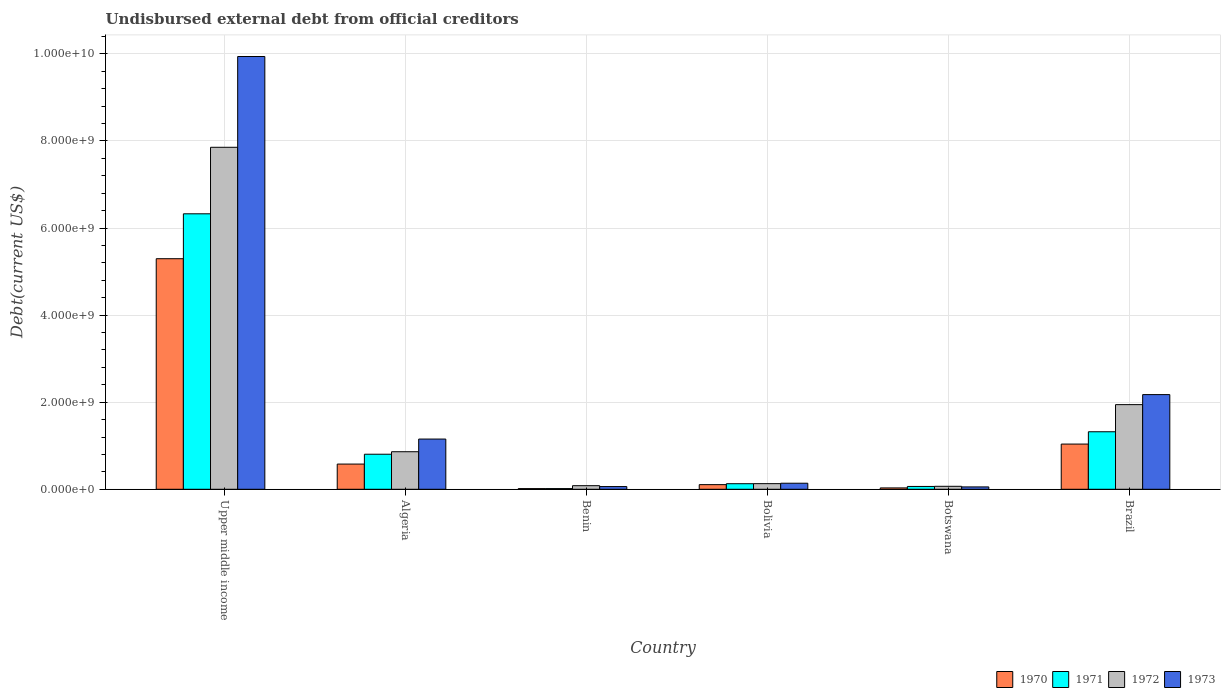How many groups of bars are there?
Your response must be concise. 6. Are the number of bars on each tick of the X-axis equal?
Offer a terse response. Yes. How many bars are there on the 5th tick from the left?
Offer a terse response. 4. How many bars are there on the 3rd tick from the right?
Keep it short and to the point. 4. What is the label of the 2nd group of bars from the left?
Your answer should be very brief. Algeria. What is the total debt in 1970 in Bolivia?
Make the answer very short. 1.07e+08. Across all countries, what is the maximum total debt in 1973?
Keep it short and to the point. 9.94e+09. Across all countries, what is the minimum total debt in 1971?
Make the answer very short. 1.57e+07. In which country was the total debt in 1971 maximum?
Offer a terse response. Upper middle income. In which country was the total debt in 1971 minimum?
Keep it short and to the point. Benin. What is the total total debt in 1972 in the graph?
Offer a terse response. 1.09e+1. What is the difference between the total debt in 1971 in Algeria and that in Bolivia?
Offer a very short reply. 6.77e+08. What is the difference between the total debt in 1973 in Benin and the total debt in 1970 in Bolivia?
Ensure brevity in your answer.  -4.46e+07. What is the average total debt in 1970 per country?
Your response must be concise. 1.18e+09. What is the difference between the total debt of/in 1971 and total debt of/in 1970 in Bolivia?
Your answer should be compact. 2.14e+07. What is the ratio of the total debt in 1972 in Botswana to that in Upper middle income?
Offer a very short reply. 0.01. Is the difference between the total debt in 1971 in Bolivia and Upper middle income greater than the difference between the total debt in 1970 in Bolivia and Upper middle income?
Your response must be concise. No. What is the difference between the highest and the second highest total debt in 1971?
Make the answer very short. 5.01e+09. What is the difference between the highest and the lowest total debt in 1971?
Your answer should be very brief. 6.31e+09. In how many countries, is the total debt in 1970 greater than the average total debt in 1970 taken over all countries?
Ensure brevity in your answer.  1. How many bars are there?
Provide a short and direct response. 24. Does the graph contain any zero values?
Offer a very short reply. No. How are the legend labels stacked?
Keep it short and to the point. Horizontal. What is the title of the graph?
Offer a very short reply. Undisbursed external debt from official creditors. Does "2008" appear as one of the legend labels in the graph?
Your response must be concise. No. What is the label or title of the X-axis?
Offer a terse response. Country. What is the label or title of the Y-axis?
Provide a short and direct response. Debt(current US$). What is the Debt(current US$) in 1970 in Upper middle income?
Give a very brief answer. 5.30e+09. What is the Debt(current US$) in 1971 in Upper middle income?
Offer a very short reply. 6.33e+09. What is the Debt(current US$) of 1972 in Upper middle income?
Offer a very short reply. 7.85e+09. What is the Debt(current US$) in 1973 in Upper middle income?
Ensure brevity in your answer.  9.94e+09. What is the Debt(current US$) in 1970 in Algeria?
Ensure brevity in your answer.  5.79e+08. What is the Debt(current US$) in 1971 in Algeria?
Provide a short and direct response. 8.05e+08. What is the Debt(current US$) of 1972 in Algeria?
Your answer should be compact. 8.62e+08. What is the Debt(current US$) in 1973 in Algeria?
Your answer should be compact. 1.15e+09. What is the Debt(current US$) of 1970 in Benin?
Make the answer very short. 1.53e+07. What is the Debt(current US$) in 1971 in Benin?
Your response must be concise. 1.57e+07. What is the Debt(current US$) in 1972 in Benin?
Provide a short and direct response. 8.25e+07. What is the Debt(current US$) in 1973 in Benin?
Your response must be concise. 6.20e+07. What is the Debt(current US$) of 1970 in Bolivia?
Keep it short and to the point. 1.07e+08. What is the Debt(current US$) in 1971 in Bolivia?
Offer a terse response. 1.28e+08. What is the Debt(current US$) of 1972 in Bolivia?
Ensure brevity in your answer.  1.29e+08. What is the Debt(current US$) in 1973 in Bolivia?
Offer a very short reply. 1.39e+08. What is the Debt(current US$) in 1970 in Botswana?
Your response must be concise. 3.11e+07. What is the Debt(current US$) of 1971 in Botswana?
Give a very brief answer. 6.50e+07. What is the Debt(current US$) in 1972 in Botswana?
Ensure brevity in your answer.  6.83e+07. What is the Debt(current US$) in 1973 in Botswana?
Provide a short and direct response. 5.44e+07. What is the Debt(current US$) in 1970 in Brazil?
Offer a very short reply. 1.04e+09. What is the Debt(current US$) in 1971 in Brazil?
Keep it short and to the point. 1.32e+09. What is the Debt(current US$) of 1972 in Brazil?
Provide a succinct answer. 1.94e+09. What is the Debt(current US$) in 1973 in Brazil?
Your answer should be compact. 2.17e+09. Across all countries, what is the maximum Debt(current US$) of 1970?
Provide a succinct answer. 5.30e+09. Across all countries, what is the maximum Debt(current US$) of 1971?
Keep it short and to the point. 6.33e+09. Across all countries, what is the maximum Debt(current US$) of 1972?
Offer a very short reply. 7.85e+09. Across all countries, what is the maximum Debt(current US$) of 1973?
Provide a short and direct response. 9.94e+09. Across all countries, what is the minimum Debt(current US$) in 1970?
Give a very brief answer. 1.53e+07. Across all countries, what is the minimum Debt(current US$) of 1971?
Make the answer very short. 1.57e+07. Across all countries, what is the minimum Debt(current US$) in 1972?
Offer a very short reply. 6.83e+07. Across all countries, what is the minimum Debt(current US$) of 1973?
Provide a short and direct response. 5.44e+07. What is the total Debt(current US$) in 1970 in the graph?
Keep it short and to the point. 7.07e+09. What is the total Debt(current US$) of 1971 in the graph?
Your answer should be very brief. 8.66e+09. What is the total Debt(current US$) of 1972 in the graph?
Your answer should be compact. 1.09e+1. What is the total Debt(current US$) of 1973 in the graph?
Your response must be concise. 1.35e+1. What is the difference between the Debt(current US$) in 1970 in Upper middle income and that in Algeria?
Give a very brief answer. 4.72e+09. What is the difference between the Debt(current US$) of 1971 in Upper middle income and that in Algeria?
Your answer should be compact. 5.52e+09. What is the difference between the Debt(current US$) in 1972 in Upper middle income and that in Algeria?
Provide a succinct answer. 6.99e+09. What is the difference between the Debt(current US$) in 1973 in Upper middle income and that in Algeria?
Ensure brevity in your answer.  8.79e+09. What is the difference between the Debt(current US$) of 1970 in Upper middle income and that in Benin?
Make the answer very short. 5.28e+09. What is the difference between the Debt(current US$) of 1971 in Upper middle income and that in Benin?
Make the answer very short. 6.31e+09. What is the difference between the Debt(current US$) in 1972 in Upper middle income and that in Benin?
Your answer should be very brief. 7.77e+09. What is the difference between the Debt(current US$) of 1973 in Upper middle income and that in Benin?
Your answer should be very brief. 9.88e+09. What is the difference between the Debt(current US$) in 1970 in Upper middle income and that in Bolivia?
Your response must be concise. 5.19e+09. What is the difference between the Debt(current US$) of 1971 in Upper middle income and that in Bolivia?
Ensure brevity in your answer.  6.20e+09. What is the difference between the Debt(current US$) of 1972 in Upper middle income and that in Bolivia?
Offer a terse response. 7.73e+09. What is the difference between the Debt(current US$) of 1973 in Upper middle income and that in Bolivia?
Make the answer very short. 9.80e+09. What is the difference between the Debt(current US$) in 1970 in Upper middle income and that in Botswana?
Your answer should be compact. 5.26e+09. What is the difference between the Debt(current US$) of 1971 in Upper middle income and that in Botswana?
Keep it short and to the point. 6.26e+09. What is the difference between the Debt(current US$) of 1972 in Upper middle income and that in Botswana?
Give a very brief answer. 7.79e+09. What is the difference between the Debt(current US$) of 1973 in Upper middle income and that in Botswana?
Provide a short and direct response. 9.88e+09. What is the difference between the Debt(current US$) of 1970 in Upper middle income and that in Brazil?
Make the answer very short. 4.26e+09. What is the difference between the Debt(current US$) of 1971 in Upper middle income and that in Brazil?
Provide a short and direct response. 5.01e+09. What is the difference between the Debt(current US$) of 1972 in Upper middle income and that in Brazil?
Offer a very short reply. 5.91e+09. What is the difference between the Debt(current US$) of 1973 in Upper middle income and that in Brazil?
Your response must be concise. 7.76e+09. What is the difference between the Debt(current US$) of 1970 in Algeria and that in Benin?
Your answer should be compact. 5.64e+08. What is the difference between the Debt(current US$) in 1971 in Algeria and that in Benin?
Keep it short and to the point. 7.89e+08. What is the difference between the Debt(current US$) in 1972 in Algeria and that in Benin?
Give a very brief answer. 7.80e+08. What is the difference between the Debt(current US$) in 1973 in Algeria and that in Benin?
Offer a very short reply. 1.09e+09. What is the difference between the Debt(current US$) of 1970 in Algeria and that in Bolivia?
Provide a short and direct response. 4.72e+08. What is the difference between the Debt(current US$) in 1971 in Algeria and that in Bolivia?
Provide a succinct answer. 6.77e+08. What is the difference between the Debt(current US$) of 1972 in Algeria and that in Bolivia?
Your response must be concise. 7.33e+08. What is the difference between the Debt(current US$) of 1973 in Algeria and that in Bolivia?
Your answer should be very brief. 1.01e+09. What is the difference between the Debt(current US$) of 1970 in Algeria and that in Botswana?
Your answer should be very brief. 5.48e+08. What is the difference between the Debt(current US$) in 1971 in Algeria and that in Botswana?
Give a very brief answer. 7.40e+08. What is the difference between the Debt(current US$) in 1972 in Algeria and that in Botswana?
Your answer should be compact. 7.94e+08. What is the difference between the Debt(current US$) of 1973 in Algeria and that in Botswana?
Offer a terse response. 1.10e+09. What is the difference between the Debt(current US$) of 1970 in Algeria and that in Brazil?
Make the answer very short. -4.59e+08. What is the difference between the Debt(current US$) of 1971 in Algeria and that in Brazil?
Your answer should be very brief. -5.16e+08. What is the difference between the Debt(current US$) in 1972 in Algeria and that in Brazil?
Provide a short and direct response. -1.08e+09. What is the difference between the Debt(current US$) of 1973 in Algeria and that in Brazil?
Keep it short and to the point. -1.02e+09. What is the difference between the Debt(current US$) in 1970 in Benin and that in Bolivia?
Provide a short and direct response. -9.12e+07. What is the difference between the Debt(current US$) of 1971 in Benin and that in Bolivia?
Make the answer very short. -1.12e+08. What is the difference between the Debt(current US$) of 1972 in Benin and that in Bolivia?
Your response must be concise. -4.66e+07. What is the difference between the Debt(current US$) in 1973 in Benin and that in Bolivia?
Your response must be concise. -7.69e+07. What is the difference between the Debt(current US$) in 1970 in Benin and that in Botswana?
Make the answer very short. -1.58e+07. What is the difference between the Debt(current US$) of 1971 in Benin and that in Botswana?
Provide a succinct answer. -4.93e+07. What is the difference between the Debt(current US$) of 1972 in Benin and that in Botswana?
Provide a succinct answer. 1.42e+07. What is the difference between the Debt(current US$) in 1973 in Benin and that in Botswana?
Provide a short and direct response. 7.61e+06. What is the difference between the Debt(current US$) of 1970 in Benin and that in Brazil?
Offer a very short reply. -1.02e+09. What is the difference between the Debt(current US$) in 1971 in Benin and that in Brazil?
Offer a terse response. -1.31e+09. What is the difference between the Debt(current US$) of 1972 in Benin and that in Brazil?
Provide a succinct answer. -1.86e+09. What is the difference between the Debt(current US$) of 1973 in Benin and that in Brazil?
Ensure brevity in your answer.  -2.11e+09. What is the difference between the Debt(current US$) in 1970 in Bolivia and that in Botswana?
Your response must be concise. 7.55e+07. What is the difference between the Debt(current US$) of 1971 in Bolivia and that in Botswana?
Offer a terse response. 6.29e+07. What is the difference between the Debt(current US$) in 1972 in Bolivia and that in Botswana?
Offer a terse response. 6.09e+07. What is the difference between the Debt(current US$) in 1973 in Bolivia and that in Botswana?
Offer a terse response. 8.45e+07. What is the difference between the Debt(current US$) of 1970 in Bolivia and that in Brazil?
Your response must be concise. -9.32e+08. What is the difference between the Debt(current US$) in 1971 in Bolivia and that in Brazil?
Give a very brief answer. -1.19e+09. What is the difference between the Debt(current US$) in 1972 in Bolivia and that in Brazil?
Provide a succinct answer. -1.82e+09. What is the difference between the Debt(current US$) of 1973 in Bolivia and that in Brazil?
Offer a terse response. -2.04e+09. What is the difference between the Debt(current US$) of 1970 in Botswana and that in Brazil?
Make the answer very short. -1.01e+09. What is the difference between the Debt(current US$) in 1971 in Botswana and that in Brazil?
Offer a terse response. -1.26e+09. What is the difference between the Debt(current US$) in 1972 in Botswana and that in Brazil?
Your answer should be very brief. -1.88e+09. What is the difference between the Debt(current US$) of 1973 in Botswana and that in Brazil?
Your response must be concise. -2.12e+09. What is the difference between the Debt(current US$) of 1970 in Upper middle income and the Debt(current US$) of 1971 in Algeria?
Your response must be concise. 4.49e+09. What is the difference between the Debt(current US$) of 1970 in Upper middle income and the Debt(current US$) of 1972 in Algeria?
Offer a very short reply. 4.43e+09. What is the difference between the Debt(current US$) in 1970 in Upper middle income and the Debt(current US$) in 1973 in Algeria?
Provide a succinct answer. 4.14e+09. What is the difference between the Debt(current US$) in 1971 in Upper middle income and the Debt(current US$) in 1972 in Algeria?
Make the answer very short. 5.46e+09. What is the difference between the Debt(current US$) of 1971 in Upper middle income and the Debt(current US$) of 1973 in Algeria?
Keep it short and to the point. 5.17e+09. What is the difference between the Debt(current US$) of 1972 in Upper middle income and the Debt(current US$) of 1973 in Algeria?
Provide a short and direct response. 6.70e+09. What is the difference between the Debt(current US$) in 1970 in Upper middle income and the Debt(current US$) in 1971 in Benin?
Provide a succinct answer. 5.28e+09. What is the difference between the Debt(current US$) of 1970 in Upper middle income and the Debt(current US$) of 1972 in Benin?
Your answer should be compact. 5.21e+09. What is the difference between the Debt(current US$) of 1970 in Upper middle income and the Debt(current US$) of 1973 in Benin?
Provide a short and direct response. 5.23e+09. What is the difference between the Debt(current US$) of 1971 in Upper middle income and the Debt(current US$) of 1972 in Benin?
Offer a terse response. 6.24e+09. What is the difference between the Debt(current US$) in 1971 in Upper middle income and the Debt(current US$) in 1973 in Benin?
Your answer should be very brief. 6.26e+09. What is the difference between the Debt(current US$) in 1972 in Upper middle income and the Debt(current US$) in 1973 in Benin?
Give a very brief answer. 7.79e+09. What is the difference between the Debt(current US$) in 1970 in Upper middle income and the Debt(current US$) in 1971 in Bolivia?
Ensure brevity in your answer.  5.17e+09. What is the difference between the Debt(current US$) in 1970 in Upper middle income and the Debt(current US$) in 1972 in Bolivia?
Your answer should be very brief. 5.17e+09. What is the difference between the Debt(current US$) of 1970 in Upper middle income and the Debt(current US$) of 1973 in Bolivia?
Offer a very short reply. 5.16e+09. What is the difference between the Debt(current US$) in 1971 in Upper middle income and the Debt(current US$) in 1972 in Bolivia?
Your answer should be very brief. 6.20e+09. What is the difference between the Debt(current US$) in 1971 in Upper middle income and the Debt(current US$) in 1973 in Bolivia?
Your response must be concise. 6.19e+09. What is the difference between the Debt(current US$) of 1972 in Upper middle income and the Debt(current US$) of 1973 in Bolivia?
Offer a very short reply. 7.72e+09. What is the difference between the Debt(current US$) in 1970 in Upper middle income and the Debt(current US$) in 1971 in Botswana?
Offer a terse response. 5.23e+09. What is the difference between the Debt(current US$) in 1970 in Upper middle income and the Debt(current US$) in 1972 in Botswana?
Offer a very short reply. 5.23e+09. What is the difference between the Debt(current US$) in 1970 in Upper middle income and the Debt(current US$) in 1973 in Botswana?
Provide a short and direct response. 5.24e+09. What is the difference between the Debt(current US$) in 1971 in Upper middle income and the Debt(current US$) in 1972 in Botswana?
Provide a succinct answer. 6.26e+09. What is the difference between the Debt(current US$) of 1971 in Upper middle income and the Debt(current US$) of 1973 in Botswana?
Ensure brevity in your answer.  6.27e+09. What is the difference between the Debt(current US$) of 1972 in Upper middle income and the Debt(current US$) of 1973 in Botswana?
Offer a very short reply. 7.80e+09. What is the difference between the Debt(current US$) in 1970 in Upper middle income and the Debt(current US$) in 1971 in Brazil?
Provide a short and direct response. 3.97e+09. What is the difference between the Debt(current US$) of 1970 in Upper middle income and the Debt(current US$) of 1972 in Brazil?
Your response must be concise. 3.35e+09. What is the difference between the Debt(current US$) of 1970 in Upper middle income and the Debt(current US$) of 1973 in Brazil?
Your answer should be very brief. 3.12e+09. What is the difference between the Debt(current US$) of 1971 in Upper middle income and the Debt(current US$) of 1972 in Brazil?
Provide a short and direct response. 4.38e+09. What is the difference between the Debt(current US$) of 1971 in Upper middle income and the Debt(current US$) of 1973 in Brazil?
Your answer should be very brief. 4.15e+09. What is the difference between the Debt(current US$) in 1972 in Upper middle income and the Debt(current US$) in 1973 in Brazil?
Offer a terse response. 5.68e+09. What is the difference between the Debt(current US$) of 1970 in Algeria and the Debt(current US$) of 1971 in Benin?
Your answer should be very brief. 5.63e+08. What is the difference between the Debt(current US$) of 1970 in Algeria and the Debt(current US$) of 1972 in Benin?
Make the answer very short. 4.96e+08. What is the difference between the Debt(current US$) of 1970 in Algeria and the Debt(current US$) of 1973 in Benin?
Your response must be concise. 5.17e+08. What is the difference between the Debt(current US$) in 1971 in Algeria and the Debt(current US$) in 1972 in Benin?
Keep it short and to the point. 7.22e+08. What is the difference between the Debt(current US$) of 1971 in Algeria and the Debt(current US$) of 1973 in Benin?
Your answer should be compact. 7.43e+08. What is the difference between the Debt(current US$) in 1972 in Algeria and the Debt(current US$) in 1973 in Benin?
Your answer should be very brief. 8.00e+08. What is the difference between the Debt(current US$) of 1970 in Algeria and the Debt(current US$) of 1971 in Bolivia?
Keep it short and to the point. 4.51e+08. What is the difference between the Debt(current US$) in 1970 in Algeria and the Debt(current US$) in 1972 in Bolivia?
Offer a terse response. 4.50e+08. What is the difference between the Debt(current US$) of 1970 in Algeria and the Debt(current US$) of 1973 in Bolivia?
Offer a terse response. 4.40e+08. What is the difference between the Debt(current US$) of 1971 in Algeria and the Debt(current US$) of 1972 in Bolivia?
Your answer should be very brief. 6.76e+08. What is the difference between the Debt(current US$) in 1971 in Algeria and the Debt(current US$) in 1973 in Bolivia?
Your answer should be very brief. 6.66e+08. What is the difference between the Debt(current US$) in 1972 in Algeria and the Debt(current US$) in 1973 in Bolivia?
Your answer should be compact. 7.23e+08. What is the difference between the Debt(current US$) of 1970 in Algeria and the Debt(current US$) of 1971 in Botswana?
Ensure brevity in your answer.  5.14e+08. What is the difference between the Debt(current US$) in 1970 in Algeria and the Debt(current US$) in 1972 in Botswana?
Provide a short and direct response. 5.11e+08. What is the difference between the Debt(current US$) of 1970 in Algeria and the Debt(current US$) of 1973 in Botswana?
Keep it short and to the point. 5.25e+08. What is the difference between the Debt(current US$) of 1971 in Algeria and the Debt(current US$) of 1972 in Botswana?
Your answer should be compact. 7.37e+08. What is the difference between the Debt(current US$) of 1971 in Algeria and the Debt(current US$) of 1973 in Botswana?
Offer a very short reply. 7.50e+08. What is the difference between the Debt(current US$) of 1972 in Algeria and the Debt(current US$) of 1973 in Botswana?
Provide a short and direct response. 8.08e+08. What is the difference between the Debt(current US$) of 1970 in Algeria and the Debt(current US$) of 1971 in Brazil?
Your response must be concise. -7.42e+08. What is the difference between the Debt(current US$) in 1970 in Algeria and the Debt(current US$) in 1972 in Brazil?
Make the answer very short. -1.37e+09. What is the difference between the Debt(current US$) in 1970 in Algeria and the Debt(current US$) in 1973 in Brazil?
Your answer should be compact. -1.60e+09. What is the difference between the Debt(current US$) in 1971 in Algeria and the Debt(current US$) in 1972 in Brazil?
Keep it short and to the point. -1.14e+09. What is the difference between the Debt(current US$) of 1971 in Algeria and the Debt(current US$) of 1973 in Brazil?
Your response must be concise. -1.37e+09. What is the difference between the Debt(current US$) of 1972 in Algeria and the Debt(current US$) of 1973 in Brazil?
Make the answer very short. -1.31e+09. What is the difference between the Debt(current US$) in 1970 in Benin and the Debt(current US$) in 1971 in Bolivia?
Provide a short and direct response. -1.13e+08. What is the difference between the Debt(current US$) in 1970 in Benin and the Debt(current US$) in 1972 in Bolivia?
Make the answer very short. -1.14e+08. What is the difference between the Debt(current US$) of 1970 in Benin and the Debt(current US$) of 1973 in Bolivia?
Ensure brevity in your answer.  -1.24e+08. What is the difference between the Debt(current US$) in 1971 in Benin and the Debt(current US$) in 1972 in Bolivia?
Keep it short and to the point. -1.13e+08. What is the difference between the Debt(current US$) of 1971 in Benin and the Debt(current US$) of 1973 in Bolivia?
Give a very brief answer. -1.23e+08. What is the difference between the Debt(current US$) of 1972 in Benin and the Debt(current US$) of 1973 in Bolivia?
Keep it short and to the point. -5.64e+07. What is the difference between the Debt(current US$) of 1970 in Benin and the Debt(current US$) of 1971 in Botswana?
Provide a short and direct response. -4.97e+07. What is the difference between the Debt(current US$) in 1970 in Benin and the Debt(current US$) in 1972 in Botswana?
Your answer should be very brief. -5.30e+07. What is the difference between the Debt(current US$) in 1970 in Benin and the Debt(current US$) in 1973 in Botswana?
Give a very brief answer. -3.91e+07. What is the difference between the Debt(current US$) of 1971 in Benin and the Debt(current US$) of 1972 in Botswana?
Your answer should be very brief. -5.26e+07. What is the difference between the Debt(current US$) in 1971 in Benin and the Debt(current US$) in 1973 in Botswana?
Give a very brief answer. -3.87e+07. What is the difference between the Debt(current US$) of 1972 in Benin and the Debt(current US$) of 1973 in Botswana?
Provide a short and direct response. 2.81e+07. What is the difference between the Debt(current US$) of 1970 in Benin and the Debt(current US$) of 1971 in Brazil?
Provide a short and direct response. -1.31e+09. What is the difference between the Debt(current US$) in 1970 in Benin and the Debt(current US$) in 1972 in Brazil?
Your response must be concise. -1.93e+09. What is the difference between the Debt(current US$) in 1970 in Benin and the Debt(current US$) in 1973 in Brazil?
Your response must be concise. -2.16e+09. What is the difference between the Debt(current US$) in 1971 in Benin and the Debt(current US$) in 1972 in Brazil?
Offer a terse response. -1.93e+09. What is the difference between the Debt(current US$) in 1971 in Benin and the Debt(current US$) in 1973 in Brazil?
Your response must be concise. -2.16e+09. What is the difference between the Debt(current US$) of 1972 in Benin and the Debt(current US$) of 1973 in Brazil?
Keep it short and to the point. -2.09e+09. What is the difference between the Debt(current US$) of 1970 in Bolivia and the Debt(current US$) of 1971 in Botswana?
Your answer should be compact. 4.15e+07. What is the difference between the Debt(current US$) in 1970 in Bolivia and the Debt(current US$) in 1972 in Botswana?
Keep it short and to the point. 3.83e+07. What is the difference between the Debt(current US$) of 1970 in Bolivia and the Debt(current US$) of 1973 in Botswana?
Provide a succinct answer. 5.22e+07. What is the difference between the Debt(current US$) of 1971 in Bolivia and the Debt(current US$) of 1972 in Botswana?
Offer a terse response. 5.97e+07. What is the difference between the Debt(current US$) in 1971 in Bolivia and the Debt(current US$) in 1973 in Botswana?
Make the answer very short. 7.36e+07. What is the difference between the Debt(current US$) in 1972 in Bolivia and the Debt(current US$) in 1973 in Botswana?
Ensure brevity in your answer.  7.47e+07. What is the difference between the Debt(current US$) of 1970 in Bolivia and the Debt(current US$) of 1971 in Brazil?
Your response must be concise. -1.21e+09. What is the difference between the Debt(current US$) in 1970 in Bolivia and the Debt(current US$) in 1972 in Brazil?
Offer a terse response. -1.84e+09. What is the difference between the Debt(current US$) in 1970 in Bolivia and the Debt(current US$) in 1973 in Brazil?
Keep it short and to the point. -2.07e+09. What is the difference between the Debt(current US$) of 1971 in Bolivia and the Debt(current US$) of 1972 in Brazil?
Your answer should be compact. -1.82e+09. What is the difference between the Debt(current US$) in 1971 in Bolivia and the Debt(current US$) in 1973 in Brazil?
Make the answer very short. -2.05e+09. What is the difference between the Debt(current US$) in 1972 in Bolivia and the Debt(current US$) in 1973 in Brazil?
Offer a terse response. -2.05e+09. What is the difference between the Debt(current US$) of 1970 in Botswana and the Debt(current US$) of 1971 in Brazil?
Ensure brevity in your answer.  -1.29e+09. What is the difference between the Debt(current US$) of 1970 in Botswana and the Debt(current US$) of 1972 in Brazil?
Your response must be concise. -1.91e+09. What is the difference between the Debt(current US$) of 1970 in Botswana and the Debt(current US$) of 1973 in Brazil?
Your answer should be very brief. -2.14e+09. What is the difference between the Debt(current US$) in 1971 in Botswana and the Debt(current US$) in 1972 in Brazil?
Ensure brevity in your answer.  -1.88e+09. What is the difference between the Debt(current US$) of 1971 in Botswana and the Debt(current US$) of 1973 in Brazil?
Your answer should be very brief. -2.11e+09. What is the difference between the Debt(current US$) of 1972 in Botswana and the Debt(current US$) of 1973 in Brazil?
Your answer should be compact. -2.11e+09. What is the average Debt(current US$) in 1970 per country?
Offer a very short reply. 1.18e+09. What is the average Debt(current US$) of 1971 per country?
Your response must be concise. 1.44e+09. What is the average Debt(current US$) of 1972 per country?
Offer a terse response. 1.82e+09. What is the average Debt(current US$) in 1973 per country?
Provide a succinct answer. 2.25e+09. What is the difference between the Debt(current US$) in 1970 and Debt(current US$) in 1971 in Upper middle income?
Offer a terse response. -1.03e+09. What is the difference between the Debt(current US$) of 1970 and Debt(current US$) of 1972 in Upper middle income?
Your answer should be compact. -2.56e+09. What is the difference between the Debt(current US$) of 1970 and Debt(current US$) of 1973 in Upper middle income?
Ensure brevity in your answer.  -4.64e+09. What is the difference between the Debt(current US$) in 1971 and Debt(current US$) in 1972 in Upper middle income?
Offer a very short reply. -1.53e+09. What is the difference between the Debt(current US$) of 1971 and Debt(current US$) of 1973 in Upper middle income?
Offer a very short reply. -3.61e+09. What is the difference between the Debt(current US$) in 1972 and Debt(current US$) in 1973 in Upper middle income?
Make the answer very short. -2.08e+09. What is the difference between the Debt(current US$) in 1970 and Debt(current US$) in 1971 in Algeria?
Offer a very short reply. -2.26e+08. What is the difference between the Debt(current US$) of 1970 and Debt(current US$) of 1972 in Algeria?
Provide a short and direct response. -2.83e+08. What is the difference between the Debt(current US$) of 1970 and Debt(current US$) of 1973 in Algeria?
Keep it short and to the point. -5.75e+08. What is the difference between the Debt(current US$) of 1971 and Debt(current US$) of 1972 in Algeria?
Provide a short and direct response. -5.74e+07. What is the difference between the Debt(current US$) in 1971 and Debt(current US$) in 1973 in Algeria?
Your answer should be very brief. -3.49e+08. What is the difference between the Debt(current US$) of 1972 and Debt(current US$) of 1973 in Algeria?
Provide a short and direct response. -2.91e+08. What is the difference between the Debt(current US$) in 1970 and Debt(current US$) in 1971 in Benin?
Make the answer very short. -3.83e+05. What is the difference between the Debt(current US$) in 1970 and Debt(current US$) in 1972 in Benin?
Your response must be concise. -6.72e+07. What is the difference between the Debt(current US$) in 1970 and Debt(current US$) in 1973 in Benin?
Make the answer very short. -4.67e+07. What is the difference between the Debt(current US$) of 1971 and Debt(current US$) of 1972 in Benin?
Your response must be concise. -6.68e+07. What is the difference between the Debt(current US$) in 1971 and Debt(current US$) in 1973 in Benin?
Offer a very short reply. -4.63e+07. What is the difference between the Debt(current US$) in 1972 and Debt(current US$) in 1973 in Benin?
Provide a short and direct response. 2.05e+07. What is the difference between the Debt(current US$) of 1970 and Debt(current US$) of 1971 in Bolivia?
Make the answer very short. -2.14e+07. What is the difference between the Debt(current US$) of 1970 and Debt(current US$) of 1972 in Bolivia?
Your answer should be compact. -2.26e+07. What is the difference between the Debt(current US$) in 1970 and Debt(current US$) in 1973 in Bolivia?
Give a very brief answer. -3.24e+07. What is the difference between the Debt(current US$) in 1971 and Debt(current US$) in 1972 in Bolivia?
Keep it short and to the point. -1.17e+06. What is the difference between the Debt(current US$) of 1971 and Debt(current US$) of 1973 in Bolivia?
Provide a short and direct response. -1.10e+07. What is the difference between the Debt(current US$) of 1972 and Debt(current US$) of 1973 in Bolivia?
Keep it short and to the point. -9.80e+06. What is the difference between the Debt(current US$) of 1970 and Debt(current US$) of 1971 in Botswana?
Your answer should be compact. -3.39e+07. What is the difference between the Debt(current US$) in 1970 and Debt(current US$) in 1972 in Botswana?
Provide a short and direct response. -3.72e+07. What is the difference between the Debt(current US$) in 1970 and Debt(current US$) in 1973 in Botswana?
Provide a short and direct response. -2.33e+07. What is the difference between the Debt(current US$) of 1971 and Debt(current US$) of 1972 in Botswana?
Make the answer very short. -3.24e+06. What is the difference between the Debt(current US$) of 1971 and Debt(current US$) of 1973 in Botswana?
Ensure brevity in your answer.  1.06e+07. What is the difference between the Debt(current US$) of 1972 and Debt(current US$) of 1973 in Botswana?
Your answer should be very brief. 1.39e+07. What is the difference between the Debt(current US$) of 1970 and Debt(current US$) of 1971 in Brazil?
Your response must be concise. -2.83e+08. What is the difference between the Debt(current US$) of 1970 and Debt(current US$) of 1972 in Brazil?
Keep it short and to the point. -9.06e+08. What is the difference between the Debt(current US$) in 1970 and Debt(current US$) in 1973 in Brazil?
Make the answer very short. -1.14e+09. What is the difference between the Debt(current US$) in 1971 and Debt(current US$) in 1972 in Brazil?
Provide a short and direct response. -6.23e+08. What is the difference between the Debt(current US$) of 1971 and Debt(current US$) of 1973 in Brazil?
Provide a succinct answer. -8.53e+08. What is the difference between the Debt(current US$) in 1972 and Debt(current US$) in 1973 in Brazil?
Offer a terse response. -2.30e+08. What is the ratio of the Debt(current US$) of 1970 in Upper middle income to that in Algeria?
Ensure brevity in your answer.  9.15. What is the ratio of the Debt(current US$) in 1971 in Upper middle income to that in Algeria?
Offer a very short reply. 7.86. What is the ratio of the Debt(current US$) of 1972 in Upper middle income to that in Algeria?
Your answer should be compact. 9.11. What is the ratio of the Debt(current US$) of 1973 in Upper middle income to that in Algeria?
Your answer should be very brief. 8.62. What is the ratio of the Debt(current US$) of 1970 in Upper middle income to that in Benin?
Offer a very short reply. 346.37. What is the ratio of the Debt(current US$) of 1971 in Upper middle income to that in Benin?
Provide a succinct answer. 403.72. What is the ratio of the Debt(current US$) in 1972 in Upper middle income to that in Benin?
Make the answer very short. 95.21. What is the ratio of the Debt(current US$) in 1973 in Upper middle income to that in Benin?
Provide a succinct answer. 160.36. What is the ratio of the Debt(current US$) in 1970 in Upper middle income to that in Bolivia?
Keep it short and to the point. 49.71. What is the ratio of the Debt(current US$) of 1971 in Upper middle income to that in Bolivia?
Your answer should be compact. 49.45. What is the ratio of the Debt(current US$) in 1972 in Upper middle income to that in Bolivia?
Keep it short and to the point. 60.83. What is the ratio of the Debt(current US$) of 1973 in Upper middle income to that in Bolivia?
Keep it short and to the point. 71.55. What is the ratio of the Debt(current US$) of 1970 in Upper middle income to that in Botswana?
Keep it short and to the point. 170.41. What is the ratio of the Debt(current US$) in 1971 in Upper middle income to that in Botswana?
Provide a succinct answer. 97.31. What is the ratio of the Debt(current US$) in 1972 in Upper middle income to that in Botswana?
Keep it short and to the point. 115.07. What is the ratio of the Debt(current US$) in 1973 in Upper middle income to that in Botswana?
Your response must be concise. 182.81. What is the ratio of the Debt(current US$) in 1970 in Upper middle income to that in Brazil?
Make the answer very short. 5.1. What is the ratio of the Debt(current US$) of 1971 in Upper middle income to that in Brazil?
Offer a very short reply. 4.79. What is the ratio of the Debt(current US$) in 1972 in Upper middle income to that in Brazil?
Make the answer very short. 4.04. What is the ratio of the Debt(current US$) of 1973 in Upper middle income to that in Brazil?
Make the answer very short. 4.57. What is the ratio of the Debt(current US$) of 1970 in Algeria to that in Benin?
Provide a succinct answer. 37.87. What is the ratio of the Debt(current US$) in 1971 in Algeria to that in Benin?
Make the answer very short. 51.36. What is the ratio of the Debt(current US$) of 1972 in Algeria to that in Benin?
Your response must be concise. 10.45. What is the ratio of the Debt(current US$) of 1973 in Algeria to that in Benin?
Offer a very short reply. 18.61. What is the ratio of the Debt(current US$) of 1970 in Algeria to that in Bolivia?
Offer a terse response. 5.43. What is the ratio of the Debt(current US$) of 1971 in Algeria to that in Bolivia?
Keep it short and to the point. 6.29. What is the ratio of the Debt(current US$) in 1972 in Algeria to that in Bolivia?
Provide a short and direct response. 6.68. What is the ratio of the Debt(current US$) in 1973 in Algeria to that in Bolivia?
Give a very brief answer. 8.3. What is the ratio of the Debt(current US$) in 1970 in Algeria to that in Botswana?
Provide a short and direct response. 18.63. What is the ratio of the Debt(current US$) of 1971 in Algeria to that in Botswana?
Provide a succinct answer. 12.38. What is the ratio of the Debt(current US$) in 1972 in Algeria to that in Botswana?
Your answer should be very brief. 12.63. What is the ratio of the Debt(current US$) in 1973 in Algeria to that in Botswana?
Make the answer very short. 21.22. What is the ratio of the Debt(current US$) of 1970 in Algeria to that in Brazil?
Keep it short and to the point. 0.56. What is the ratio of the Debt(current US$) in 1971 in Algeria to that in Brazil?
Keep it short and to the point. 0.61. What is the ratio of the Debt(current US$) in 1972 in Algeria to that in Brazil?
Ensure brevity in your answer.  0.44. What is the ratio of the Debt(current US$) of 1973 in Algeria to that in Brazil?
Give a very brief answer. 0.53. What is the ratio of the Debt(current US$) of 1970 in Benin to that in Bolivia?
Offer a very short reply. 0.14. What is the ratio of the Debt(current US$) of 1971 in Benin to that in Bolivia?
Offer a terse response. 0.12. What is the ratio of the Debt(current US$) in 1972 in Benin to that in Bolivia?
Your response must be concise. 0.64. What is the ratio of the Debt(current US$) in 1973 in Benin to that in Bolivia?
Your answer should be very brief. 0.45. What is the ratio of the Debt(current US$) of 1970 in Benin to that in Botswana?
Provide a succinct answer. 0.49. What is the ratio of the Debt(current US$) in 1971 in Benin to that in Botswana?
Your response must be concise. 0.24. What is the ratio of the Debt(current US$) of 1972 in Benin to that in Botswana?
Ensure brevity in your answer.  1.21. What is the ratio of the Debt(current US$) of 1973 in Benin to that in Botswana?
Your answer should be compact. 1.14. What is the ratio of the Debt(current US$) of 1970 in Benin to that in Brazil?
Your response must be concise. 0.01. What is the ratio of the Debt(current US$) in 1971 in Benin to that in Brazil?
Your response must be concise. 0.01. What is the ratio of the Debt(current US$) in 1972 in Benin to that in Brazil?
Your answer should be compact. 0.04. What is the ratio of the Debt(current US$) in 1973 in Benin to that in Brazil?
Offer a terse response. 0.03. What is the ratio of the Debt(current US$) of 1970 in Bolivia to that in Botswana?
Offer a very short reply. 3.43. What is the ratio of the Debt(current US$) in 1971 in Bolivia to that in Botswana?
Keep it short and to the point. 1.97. What is the ratio of the Debt(current US$) in 1972 in Bolivia to that in Botswana?
Your answer should be compact. 1.89. What is the ratio of the Debt(current US$) of 1973 in Bolivia to that in Botswana?
Your response must be concise. 2.56. What is the ratio of the Debt(current US$) in 1970 in Bolivia to that in Brazil?
Ensure brevity in your answer.  0.1. What is the ratio of the Debt(current US$) in 1971 in Bolivia to that in Brazil?
Your answer should be compact. 0.1. What is the ratio of the Debt(current US$) of 1972 in Bolivia to that in Brazil?
Your answer should be compact. 0.07. What is the ratio of the Debt(current US$) of 1973 in Bolivia to that in Brazil?
Keep it short and to the point. 0.06. What is the ratio of the Debt(current US$) in 1970 in Botswana to that in Brazil?
Make the answer very short. 0.03. What is the ratio of the Debt(current US$) of 1971 in Botswana to that in Brazil?
Ensure brevity in your answer.  0.05. What is the ratio of the Debt(current US$) of 1972 in Botswana to that in Brazil?
Offer a terse response. 0.04. What is the ratio of the Debt(current US$) in 1973 in Botswana to that in Brazil?
Your answer should be very brief. 0.03. What is the difference between the highest and the second highest Debt(current US$) in 1970?
Offer a terse response. 4.26e+09. What is the difference between the highest and the second highest Debt(current US$) in 1971?
Give a very brief answer. 5.01e+09. What is the difference between the highest and the second highest Debt(current US$) in 1972?
Your response must be concise. 5.91e+09. What is the difference between the highest and the second highest Debt(current US$) of 1973?
Make the answer very short. 7.76e+09. What is the difference between the highest and the lowest Debt(current US$) in 1970?
Provide a succinct answer. 5.28e+09. What is the difference between the highest and the lowest Debt(current US$) in 1971?
Offer a terse response. 6.31e+09. What is the difference between the highest and the lowest Debt(current US$) in 1972?
Offer a very short reply. 7.79e+09. What is the difference between the highest and the lowest Debt(current US$) of 1973?
Give a very brief answer. 9.88e+09. 